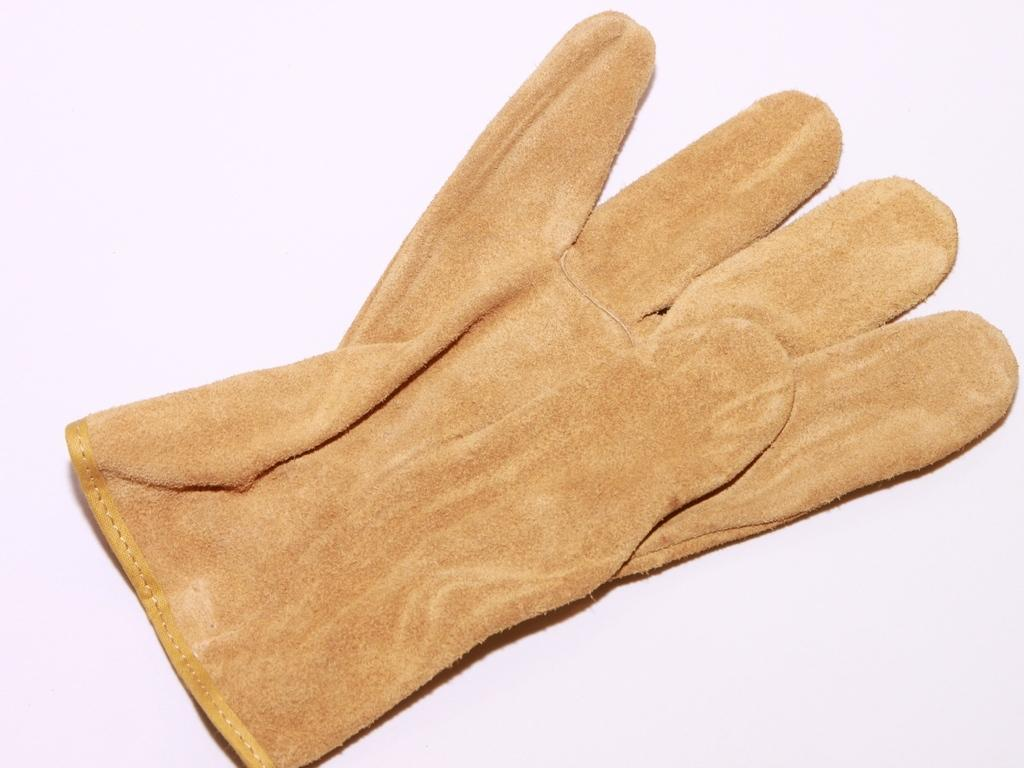What object is present on the platform in the image? There is a glove on the platform in the image. Can you describe the position or orientation of the glove on the platform? Unfortunately, the provided facts do not give enough information to describe the position or orientation of the glove on the platform. How many branches can be seen on the girl in the image? There is no girl present in the image, and therefore no branches can be seen on her. 